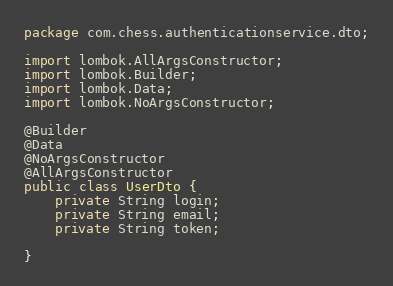<code> <loc_0><loc_0><loc_500><loc_500><_Java_>package com.chess.authenticationservice.dto;

import lombok.AllArgsConstructor;
import lombok.Builder;
import lombok.Data;
import lombok.NoArgsConstructor;

@Builder
@Data
@NoArgsConstructor
@AllArgsConstructor
public class UserDto {
    private String login;
    private String email;
    private String token;

}

</code> 